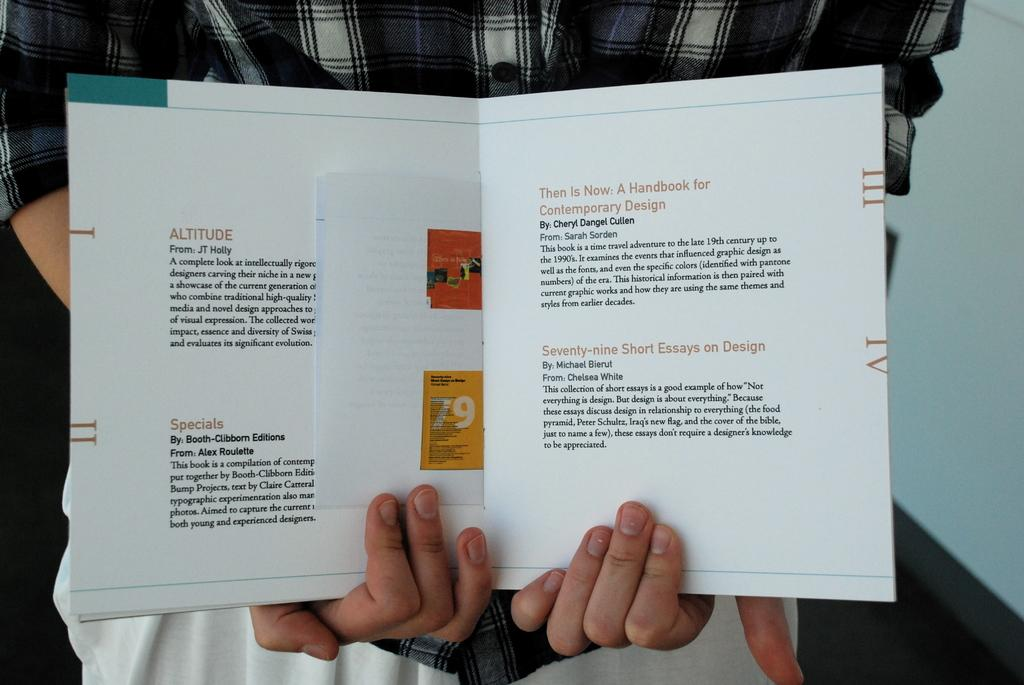<image>
Describe the image concisely. Person showing off a page that starts off by talking about Altitude. 